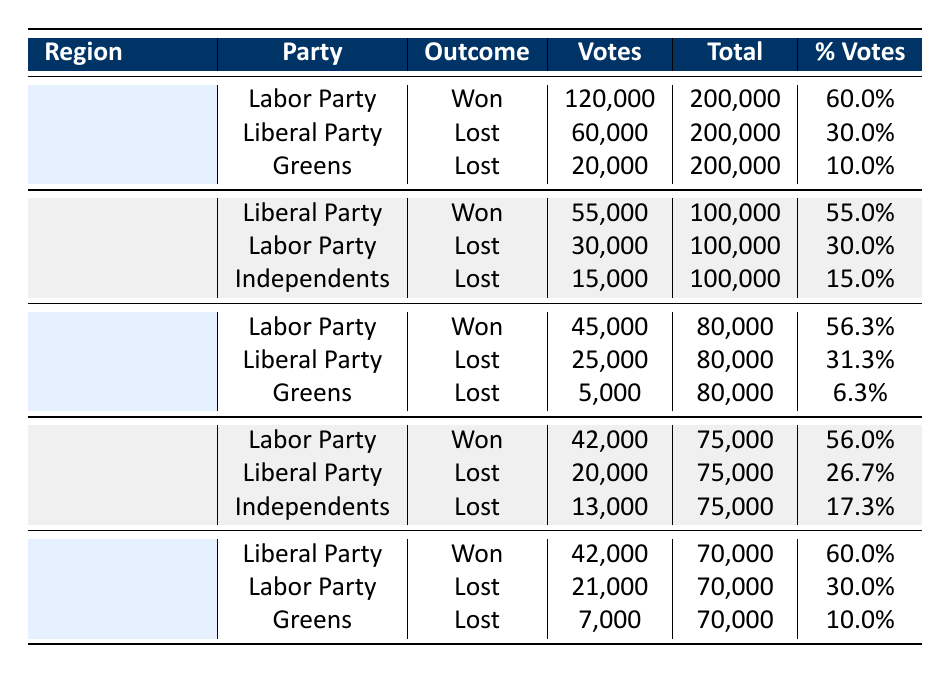What was the total number of votes received by the Labor Party in Melbourne? The Labor Party received 120,000 votes in Melbourne according to the table.
Answer: 120,000 Which political party won in Ballarat? The table shows that the Labor Party won in Ballarat with 45,000 votes.
Answer: Labor Party How many total votes were cast in Geelong? In Geelong, a total of 100,000 votes were cast as indicated in the table.
Answer: 100,000 What percentage of votes did the Liberal Party receive in Warrnambool? The Liberal Party received 42,000 votes which is calculated as 60.0% of the total 70,000 votes in Warrnambool.
Answer: 60.0% Did the Greens win in any region? No, the table indicates that the Greens lost in all regions they contested, confirming they did not win in any.
Answer: No What is the difference in votes received by the Labor Party between Bendigo and Ballarat? In Bendigo, the Labor Party received 42,000 votes, while in Ballarat they received 45,000 votes. The difference is 45,000 - 42,000 = 3,000 votes.
Answer: 3,000 Which region had the closest vote percentage between the two top parties? In Bendigo, the Labor Party won with 56.0% and the Liberal Party received 26.7%, the difference is the least compared to other regions, indicating a closer race.
Answer: Bendigo What was the combined vote percentage of the losing parties in Melbourne? The losing parties in Melbourne were the Liberal Party (30.0%) and Greens (10.0%). Their combined vote percentage is 30.0% + 10.0% = 40.0%.
Answer: 40.0% Which political party had the lowest number of votes overall? The Greens received the least number of votes overall with 5,000 in Ballarat.
Answer: Greens 